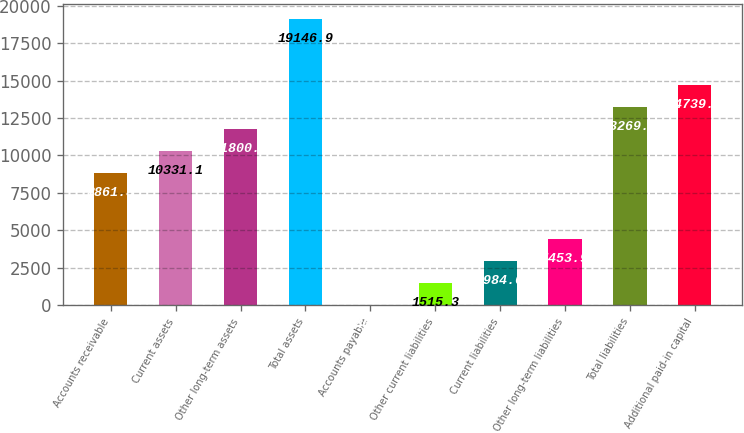Convert chart to OTSL. <chart><loc_0><loc_0><loc_500><loc_500><bar_chart><fcel>Accounts receivable<fcel>Current assets<fcel>Other long-term assets<fcel>Total assets<fcel>Accounts payable<fcel>Other current liabilities<fcel>Current liabilities<fcel>Other long-term liabilities<fcel>Total liabilities<fcel>Additional paid-in capital<nl><fcel>8861.8<fcel>10331.1<fcel>11800.4<fcel>19146.9<fcel>46<fcel>1515.3<fcel>2984.6<fcel>4453.9<fcel>13269.7<fcel>14739<nl></chart> 